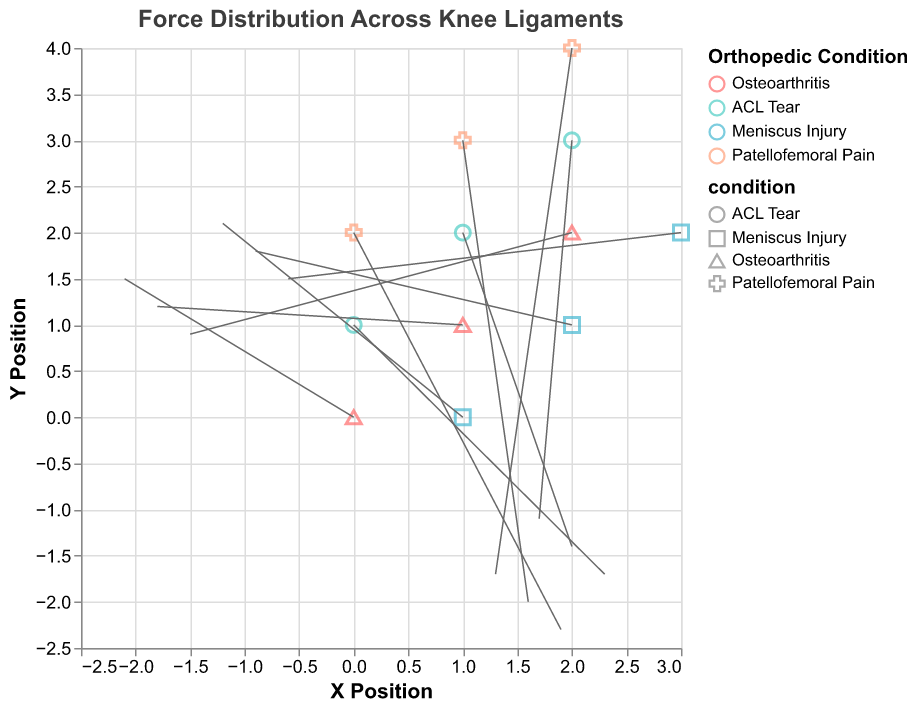What is the title of the figure? The title of the figure is displayed at the top, indicating the subject of the visualization.
Answer: Force Distribution Across Knee Ligaments How many different orthopedic conditions are represented in the figure? The legend to the right of the plot shows the different colors used for each condition, each representing one orthopedic condition. There are four conditions: Osteoarthritis, ACL Tear, Meniscus Injury, and Patellofemoral Pain.
Answer: 4 Which orthopedic condition shows the highest vertical force component (v) at any position? By examining the lengths of the vectors on the plot (specifically the vertical components), the ACL Tear condition shows the highest vertical force component at position (0,1) with v = -1.7.
Answer: ACL Tear What is the direction of the force for the data point at position (0,0) for Osteoarthritis? The vector at (0,0) for Osteoarthritis points in the direction specified by its components (u, v), which are (-2.1, 1.5). This direction is towards left and upwards.
Answer: Left and Upwards Which condition has the most leftward force component (u)? By examining the vectors' horizontal components (u), the largest negative value for u is in the Osteoarthritis condition at position (0,0) with u = -2.1.
Answer: Osteoarthritis What is the range of x positions used in this figure? The x values shown in the grid lines and data points span from 0 to 3, as indicated by the position of the points along the x-axis.
Answer: 0 to 3 How does the force distribution for Meniscus Injury compare to that of Patellofemoral Pain? Meniscus Injury vectors tend to point mostly upwards (positive vertical component), while Patellofemoral Pain vectors predominantly point downwards (negative vertical component). In addition, Meniscus Injury vectors have smaller horizontal components (u) compared to those of Patellofemoral Pain.
Answer: Meniscus Injury forces are mostly upwards, Patellofemoral Pain forces are mostly downwards Are any of the force vectors for the ACL Tear pointing strictly vertically? "Strictly vertically" means the horizontal component (u) is zero. None of the vectors for ACL Tear have u as zero; they all have positive horizontal components.
Answer: No Is there any condition where all vectors have a negative vertical component (v)? By examining the v components of all vectors, it's evident that Patellofemoral Pain is the only condition where all vectors have a negative v component.
Answer: Yes, Patellofemoral Pain Which condition has the shortest overall force vector at any position? The overall force vector length can be determined by the magnitude formula √(u² + v²). The shortest vector is for Osteoarthritis at position (2, 2) with u = -1.5 and v = 0.9, yielding a magnitude of √((-1.5)^2 + (0.9)^2) = √(3.06) ≈ 1.75.
Answer: Osteoarthritis 